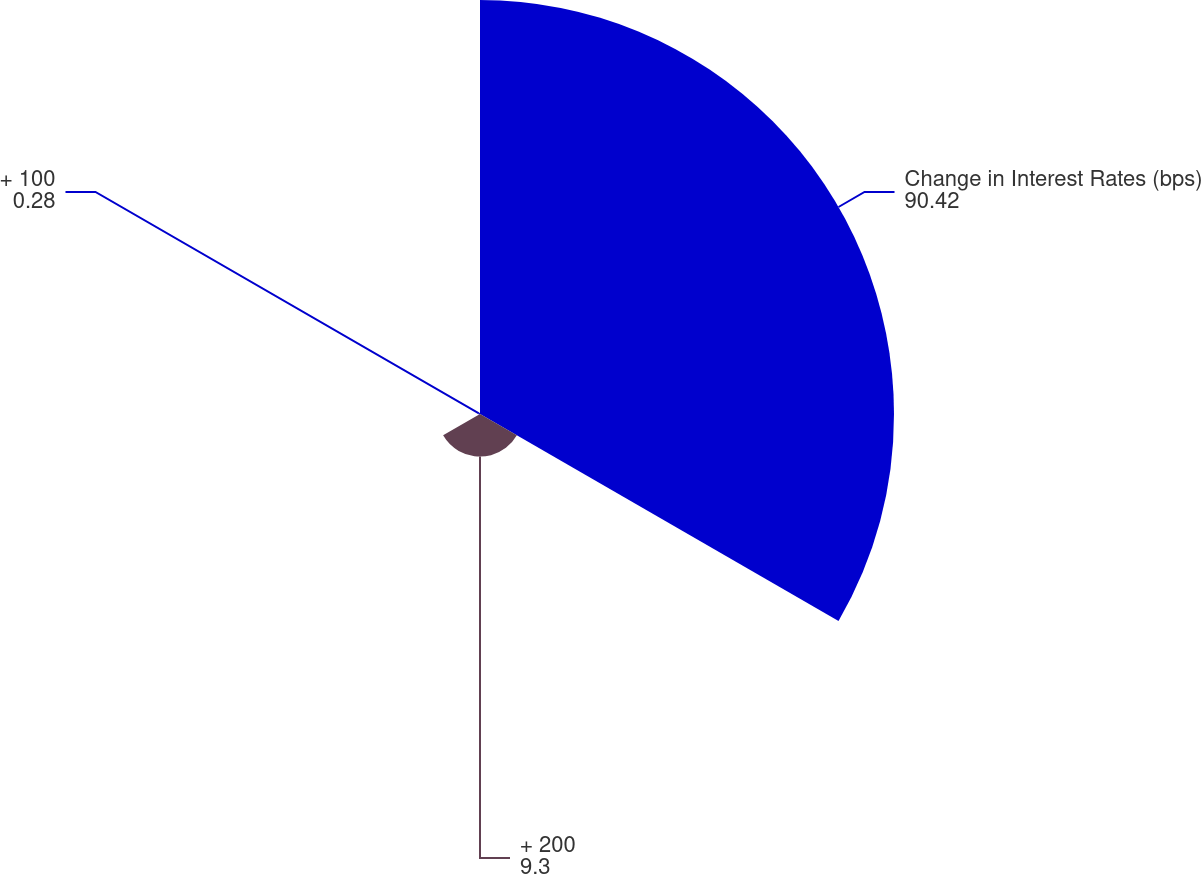Convert chart. <chart><loc_0><loc_0><loc_500><loc_500><pie_chart><fcel>Change in Interest Rates (bps)<fcel>+ 200<fcel>+ 100<nl><fcel>90.42%<fcel>9.3%<fcel>0.28%<nl></chart> 